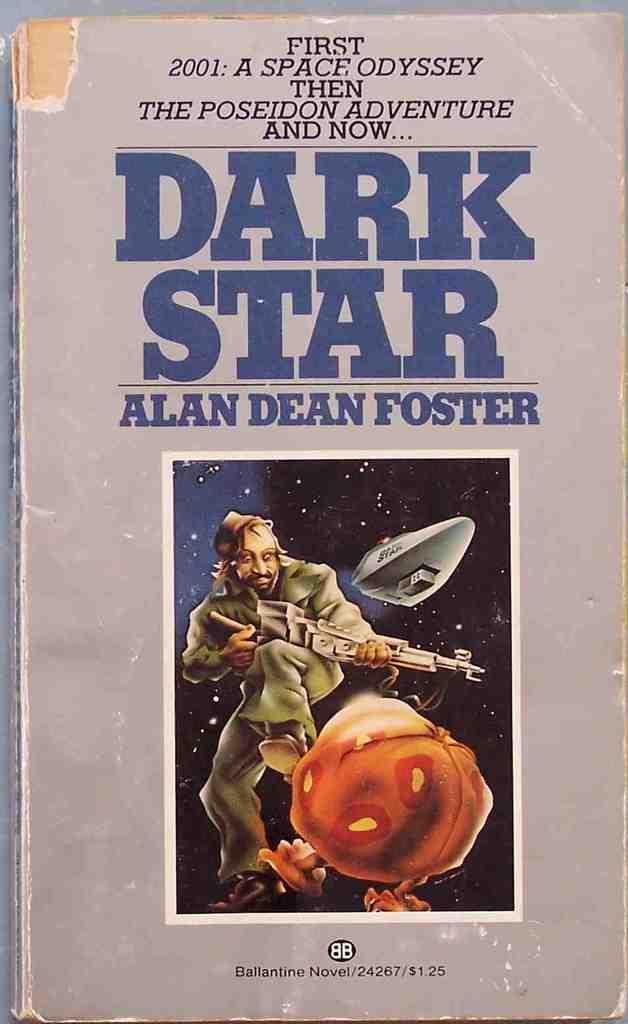Provide a one-sentence caption for the provided image. An drawing is included on the cover of the book Dark Star which has an edge missing. 